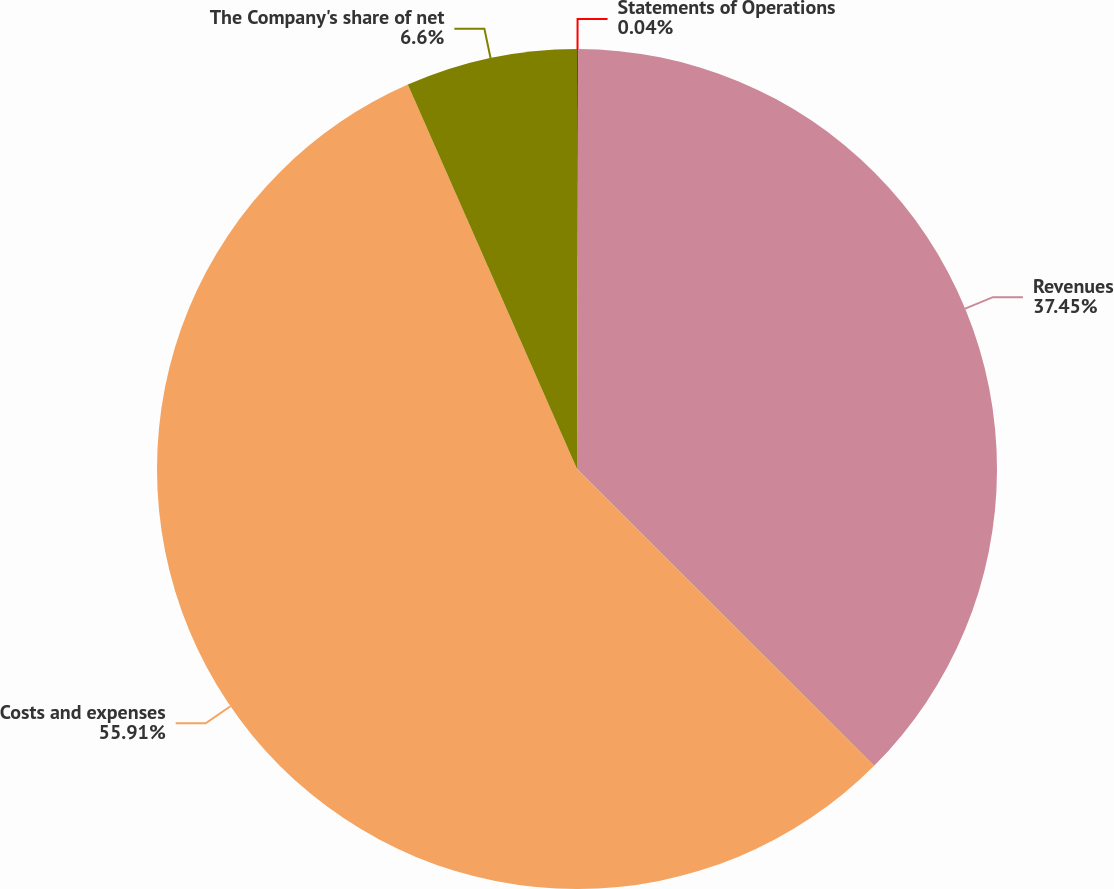Convert chart. <chart><loc_0><loc_0><loc_500><loc_500><pie_chart><fcel>Statements of Operations<fcel>Revenues<fcel>Costs and expenses<fcel>The Company's share of net<nl><fcel>0.04%<fcel>37.45%<fcel>55.91%<fcel>6.6%<nl></chart> 